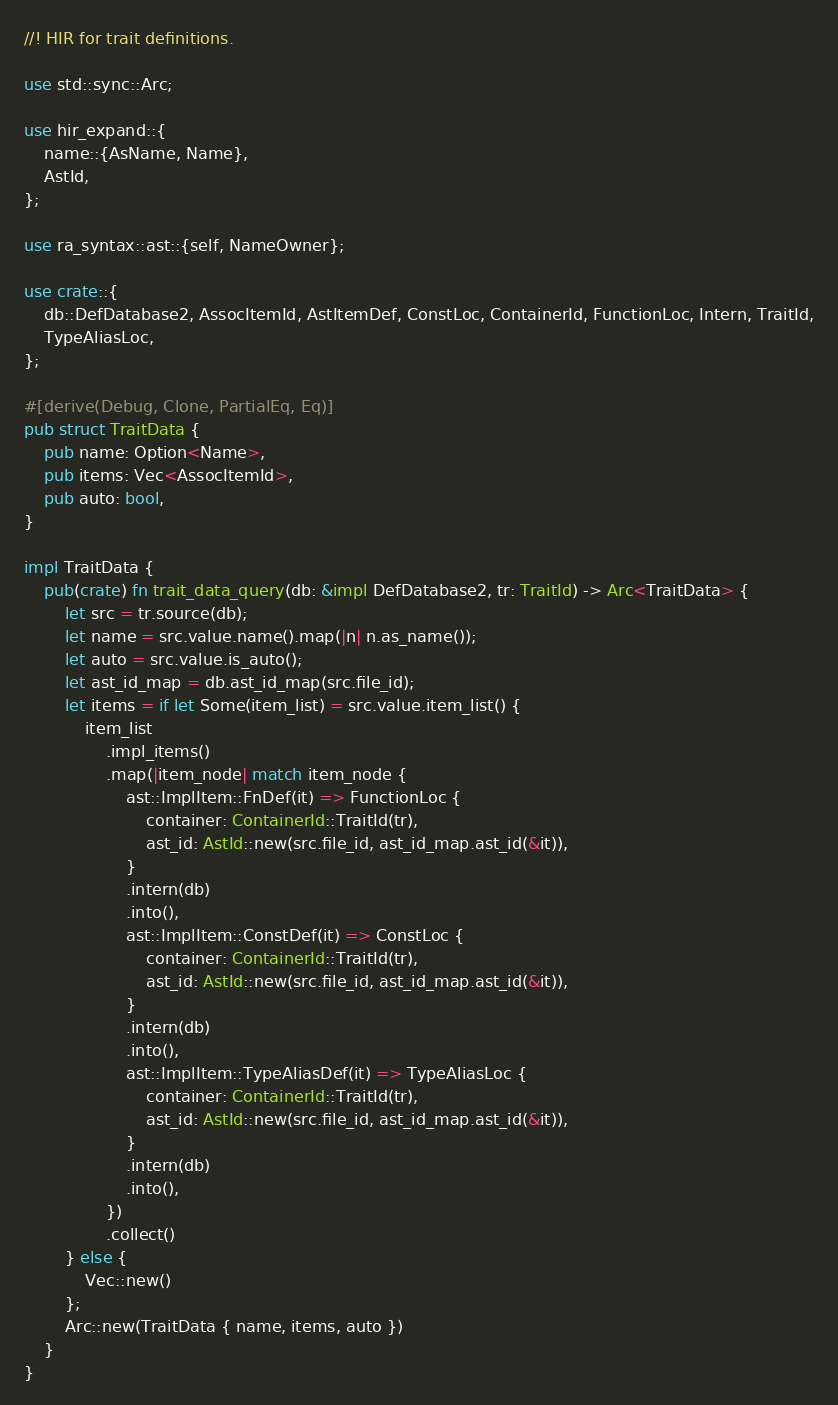Convert code to text. <code><loc_0><loc_0><loc_500><loc_500><_Rust_>//! HIR for trait definitions.

use std::sync::Arc;

use hir_expand::{
    name::{AsName, Name},
    AstId,
};

use ra_syntax::ast::{self, NameOwner};

use crate::{
    db::DefDatabase2, AssocItemId, AstItemDef, ConstLoc, ContainerId, FunctionLoc, Intern, TraitId,
    TypeAliasLoc,
};

#[derive(Debug, Clone, PartialEq, Eq)]
pub struct TraitData {
    pub name: Option<Name>,
    pub items: Vec<AssocItemId>,
    pub auto: bool,
}

impl TraitData {
    pub(crate) fn trait_data_query(db: &impl DefDatabase2, tr: TraitId) -> Arc<TraitData> {
        let src = tr.source(db);
        let name = src.value.name().map(|n| n.as_name());
        let auto = src.value.is_auto();
        let ast_id_map = db.ast_id_map(src.file_id);
        let items = if let Some(item_list) = src.value.item_list() {
            item_list
                .impl_items()
                .map(|item_node| match item_node {
                    ast::ImplItem::FnDef(it) => FunctionLoc {
                        container: ContainerId::TraitId(tr),
                        ast_id: AstId::new(src.file_id, ast_id_map.ast_id(&it)),
                    }
                    .intern(db)
                    .into(),
                    ast::ImplItem::ConstDef(it) => ConstLoc {
                        container: ContainerId::TraitId(tr),
                        ast_id: AstId::new(src.file_id, ast_id_map.ast_id(&it)),
                    }
                    .intern(db)
                    .into(),
                    ast::ImplItem::TypeAliasDef(it) => TypeAliasLoc {
                        container: ContainerId::TraitId(tr),
                        ast_id: AstId::new(src.file_id, ast_id_map.ast_id(&it)),
                    }
                    .intern(db)
                    .into(),
                })
                .collect()
        } else {
            Vec::new()
        };
        Arc::new(TraitData { name, items, auto })
    }
}
</code> 